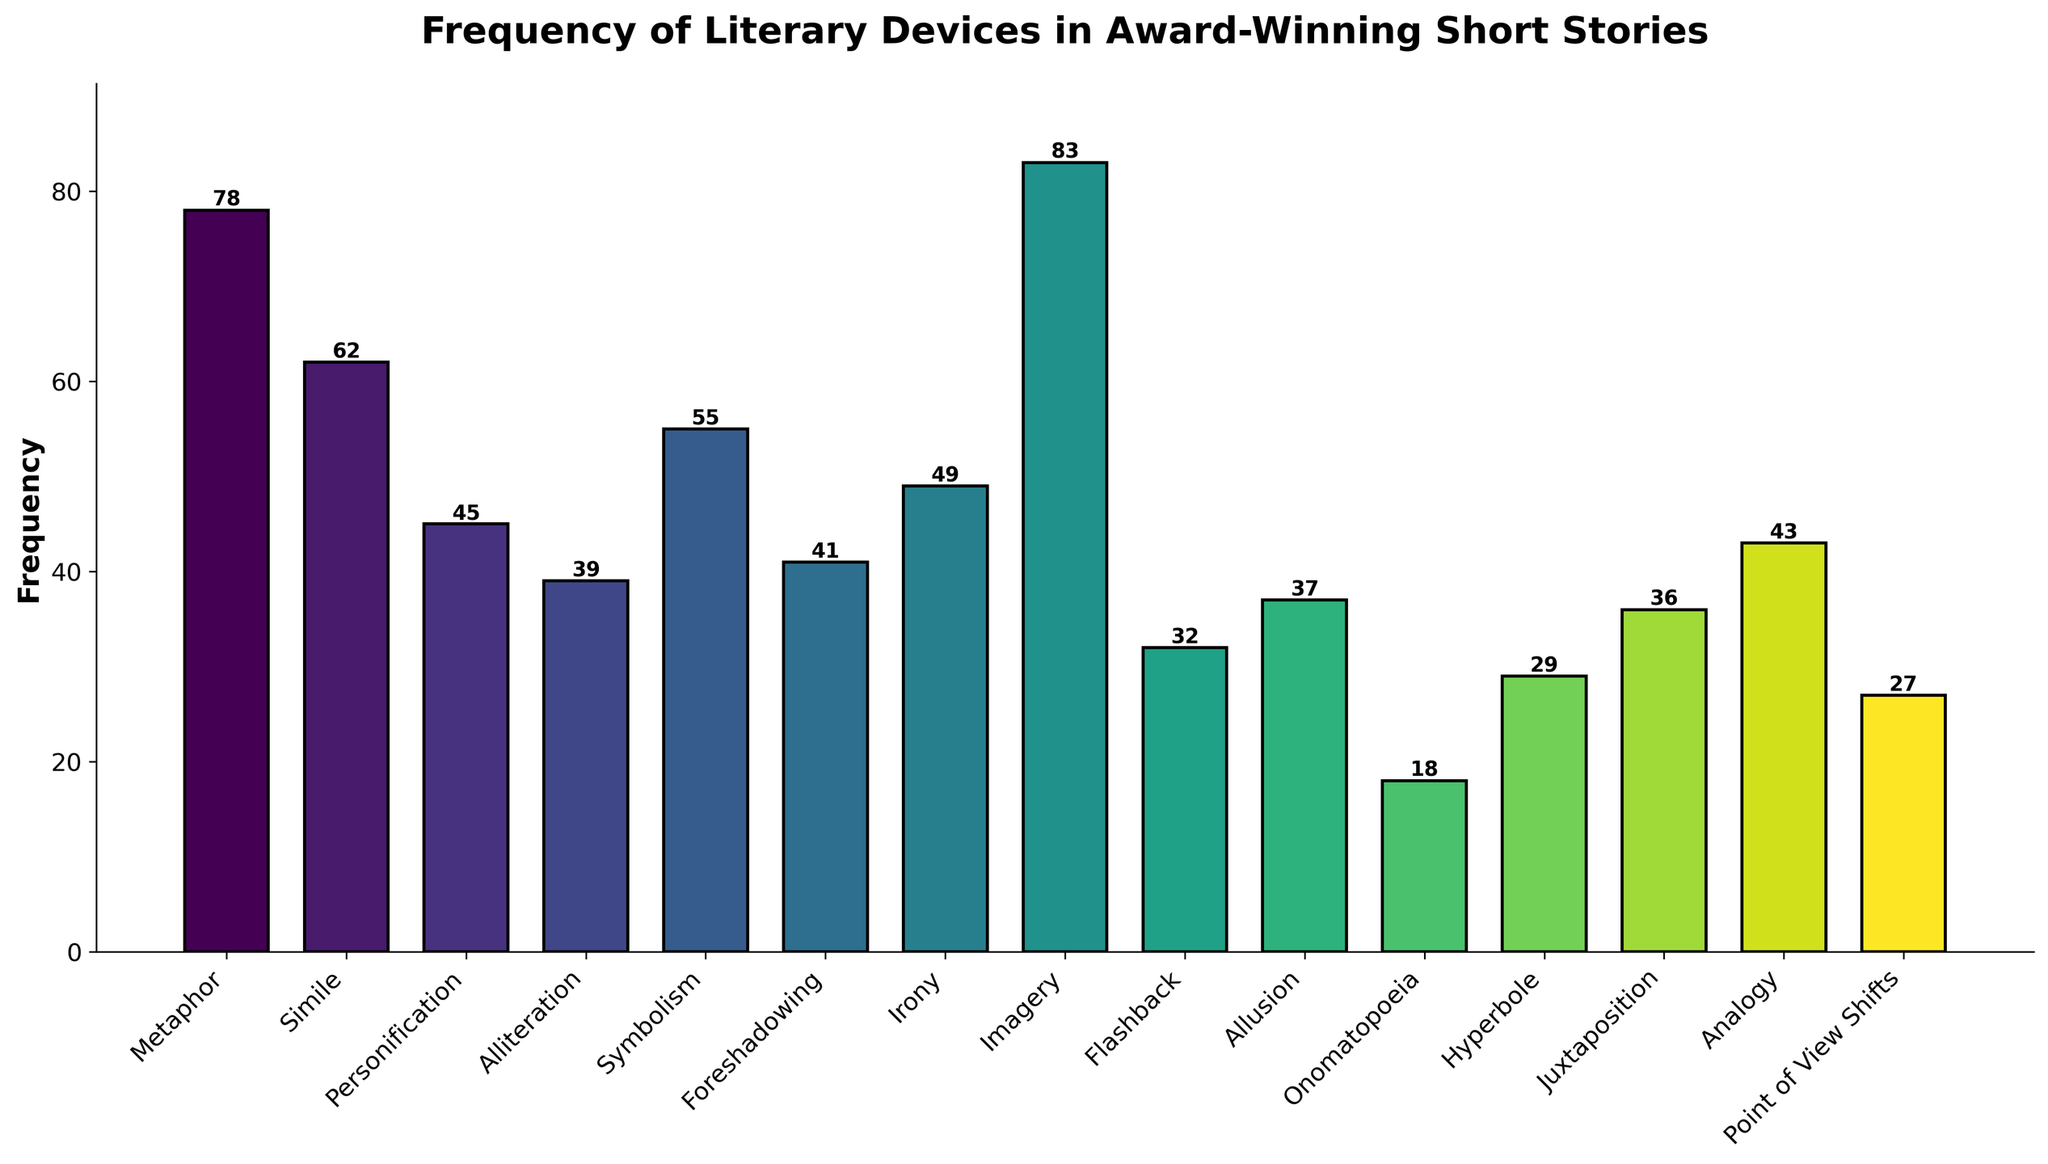What is the most frequently used literary device in award-winning short stories? By observing the heights of the bars, Imagery is the tallest bar, indicating the highest frequency.
Answer: Imagery Which literary device is used less frequently, Simile or Personification? By comparing the heights of their bars, Personification has a lower height (45) than Simile (62).
Answer: Personification What is the total frequency of Simile, Metaphor, and Symbolism combined? Add the frequencies of Simile (62), Metaphor (78), and Symbolism (55): 62 + 78 + 55 = 195
Answer: 195 How many more times is Onomatopoeia used compared to Hyperbole? Subtract the frequency of Hyperbole (29) from that of Onomatopoeia (18): 29 - 18 = 11
Answer: 11 Is the frequency of Flashback higher or lower than the median frequency of all literary devices presented? To find the median, list all frequencies in ascending order: [18, 27, 29, 32, 36, 37, 39, 41, 43, 45, 49, 55, 62, 78, 83]. The median frequency is the middle value, 41. The frequency of Flashback is 32. Comparing, 32 is lower than 41.
Answer: Lower Which literary device has the third lowest frequency? Order the frequencies from lowest to highest: [18, 27, 29, 32, 36, 37, 39, 41, 43, 45, 49, 55, 62, 78, 83]. The third lowest frequency is 29, which corresponds to Hyperbole.
Answer: Hyperbole What is the difference in frequency between Irony and Foreshadowing? Subtract the frequency of Foreshadowing (41) from that of Irony (49): 49 - 41 = 8
Answer: 8 Which literary device has a frequency closest to 40? The frequencies close to 40 are: Alliteration (39), Foreshadowing (41), and Allusion (37). The closest one is Alliteration with a frequency of 39.
Answer: Alliteration 